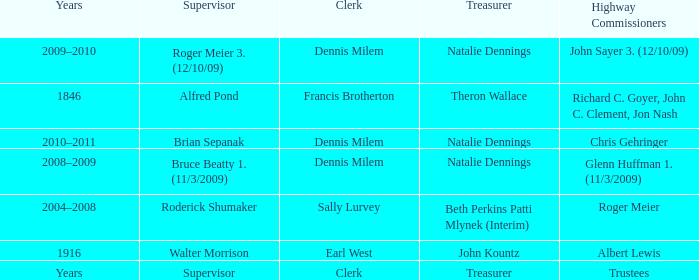Who was the clerk when the highway commissioner was Albert Lewis? Earl West. 